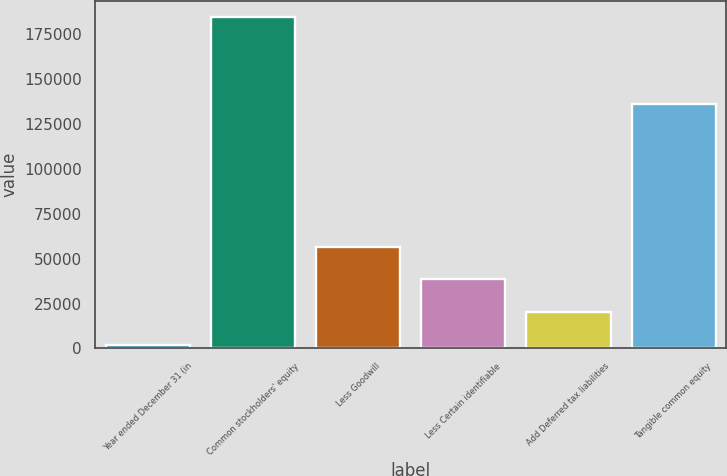Convert chart. <chart><loc_0><loc_0><loc_500><loc_500><bar_chart><fcel>Year ended December 31 (in<fcel>Common stockholders' equity<fcel>Less Goodwill<fcel>Less Certain identifiable<fcel>Add Deferred tax liabilities<fcel>Tangible common equity<nl><fcel>2012<fcel>184352<fcel>56714<fcel>38480<fcel>20246<fcel>136097<nl></chart> 